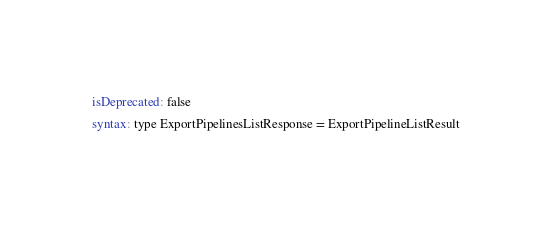Convert code to text. <code><loc_0><loc_0><loc_500><loc_500><_YAML_>isDeprecated: false
syntax: type ExportPipelinesListResponse = ExportPipelineListResult
</code> 